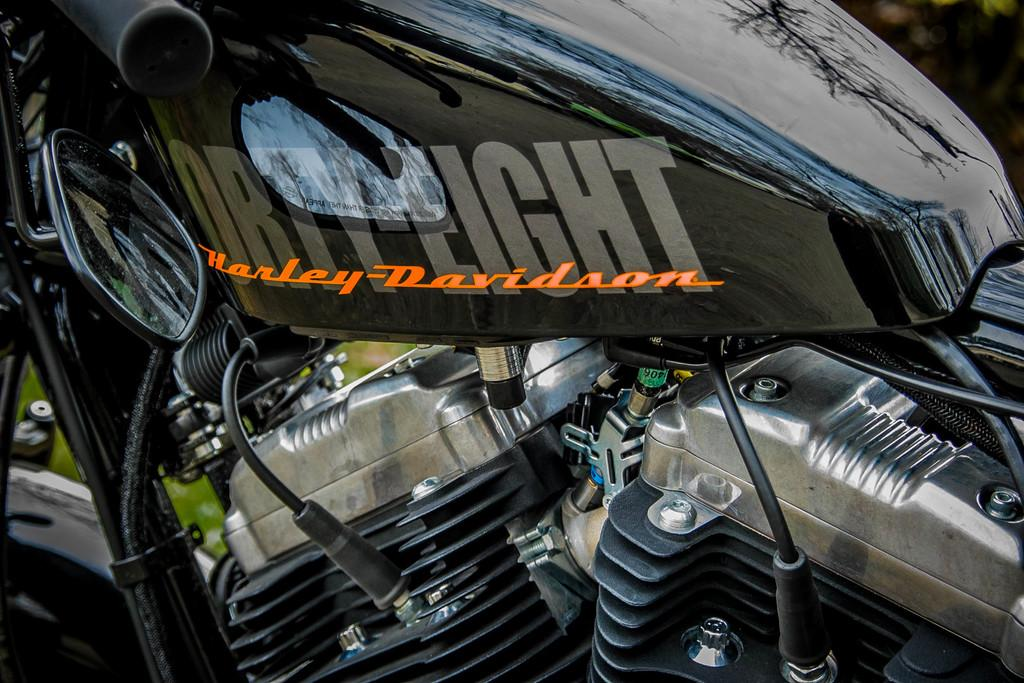What color is the bike in the image? The bike in the image is black. What parts of the bike can be seen in the image? The engine parts and cables of the bike are visible in the image. Can you describe the background of the image? The background of the image is blurry. How many potatoes are stored in the box next to the bike in the image? There is no box or potatoes present in the image. What is the bike's income based on the image? The image does not provide information about the bike's income. 